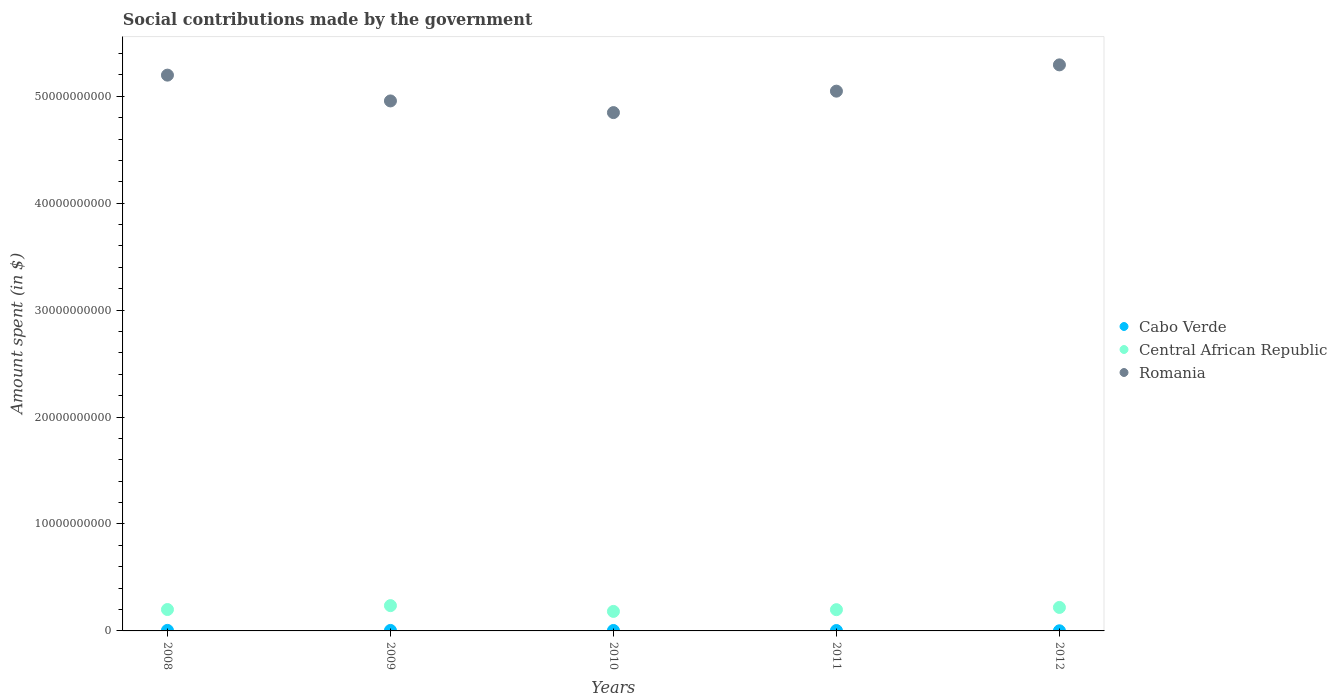How many different coloured dotlines are there?
Your answer should be compact. 3. What is the amount spent on social contributions in Central African Republic in 2012?
Provide a short and direct response. 2.20e+09. Across all years, what is the maximum amount spent on social contributions in Romania?
Offer a very short reply. 5.29e+1. Across all years, what is the minimum amount spent on social contributions in Romania?
Provide a short and direct response. 4.85e+1. In which year was the amount spent on social contributions in Central African Republic maximum?
Offer a very short reply. 2009. In which year was the amount spent on social contributions in Romania minimum?
Your answer should be compact. 2010. What is the total amount spent on social contributions in Central African Republic in the graph?
Make the answer very short. 1.04e+1. What is the difference between the amount spent on social contributions in Romania in 2009 and that in 2012?
Offer a terse response. -3.37e+09. What is the difference between the amount spent on social contributions in Cabo Verde in 2009 and the amount spent on social contributions in Romania in 2010?
Provide a succinct answer. -4.84e+1. What is the average amount spent on social contributions in Cabo Verde per year?
Provide a succinct answer. 3.73e+07. In the year 2008, what is the difference between the amount spent on social contributions in Central African Republic and amount spent on social contributions in Cabo Verde?
Ensure brevity in your answer.  1.95e+09. What is the ratio of the amount spent on social contributions in Central African Republic in 2009 to that in 2010?
Your answer should be very brief. 1.3. Is the amount spent on social contributions in Romania in 2008 less than that in 2012?
Offer a terse response. Yes. What is the difference between the highest and the second highest amount spent on social contributions in Cabo Verde?
Your answer should be very brief. 4.24e+06. What is the difference between the highest and the lowest amount spent on social contributions in Central African Republic?
Your answer should be compact. 5.41e+08. In how many years, is the amount spent on social contributions in Central African Republic greater than the average amount spent on social contributions in Central African Republic taken over all years?
Ensure brevity in your answer.  2. Does the amount spent on social contributions in Romania monotonically increase over the years?
Make the answer very short. No. Is the amount spent on social contributions in Central African Republic strictly less than the amount spent on social contributions in Romania over the years?
Make the answer very short. Yes. How many years are there in the graph?
Offer a terse response. 5. Are the values on the major ticks of Y-axis written in scientific E-notation?
Ensure brevity in your answer.  No. Does the graph contain any zero values?
Your response must be concise. No. Does the graph contain grids?
Keep it short and to the point. No. How many legend labels are there?
Provide a short and direct response. 3. How are the legend labels stacked?
Your response must be concise. Vertical. What is the title of the graph?
Your answer should be very brief. Social contributions made by the government. What is the label or title of the Y-axis?
Your answer should be compact. Amount spent (in $). What is the Amount spent (in $) in Cabo Verde in 2008?
Ensure brevity in your answer.  4.98e+07. What is the Amount spent (in $) in Central African Republic in 2008?
Offer a terse response. 2.00e+09. What is the Amount spent (in $) in Romania in 2008?
Provide a short and direct response. 5.20e+1. What is the Amount spent (in $) of Cabo Verde in 2009?
Keep it short and to the point. 4.56e+07. What is the Amount spent (in $) in Central African Republic in 2009?
Make the answer very short. 2.37e+09. What is the Amount spent (in $) in Romania in 2009?
Your response must be concise. 4.96e+1. What is the Amount spent (in $) in Cabo Verde in 2010?
Your answer should be very brief. 4.19e+07. What is the Amount spent (in $) in Central African Republic in 2010?
Give a very brief answer. 1.82e+09. What is the Amount spent (in $) of Romania in 2010?
Make the answer very short. 4.85e+1. What is the Amount spent (in $) in Cabo Verde in 2011?
Offer a very short reply. 3.65e+07. What is the Amount spent (in $) in Central African Republic in 2011?
Make the answer very short. 1.99e+09. What is the Amount spent (in $) in Romania in 2011?
Keep it short and to the point. 5.05e+1. What is the Amount spent (in $) in Cabo Verde in 2012?
Offer a very short reply. 1.29e+07. What is the Amount spent (in $) of Central African Republic in 2012?
Offer a terse response. 2.20e+09. What is the Amount spent (in $) of Romania in 2012?
Make the answer very short. 5.29e+1. Across all years, what is the maximum Amount spent (in $) of Cabo Verde?
Provide a succinct answer. 4.98e+07. Across all years, what is the maximum Amount spent (in $) in Central African Republic?
Offer a terse response. 2.37e+09. Across all years, what is the maximum Amount spent (in $) of Romania?
Your response must be concise. 5.29e+1. Across all years, what is the minimum Amount spent (in $) in Cabo Verde?
Offer a very short reply. 1.29e+07. Across all years, what is the minimum Amount spent (in $) in Central African Republic?
Give a very brief answer. 1.82e+09. Across all years, what is the minimum Amount spent (in $) in Romania?
Keep it short and to the point. 4.85e+1. What is the total Amount spent (in $) in Cabo Verde in the graph?
Offer a terse response. 1.87e+08. What is the total Amount spent (in $) in Central African Republic in the graph?
Offer a terse response. 1.04e+1. What is the total Amount spent (in $) in Romania in the graph?
Offer a very short reply. 2.53e+11. What is the difference between the Amount spent (in $) in Cabo Verde in 2008 and that in 2009?
Your response must be concise. 4.24e+06. What is the difference between the Amount spent (in $) of Central African Republic in 2008 and that in 2009?
Give a very brief answer. -3.65e+08. What is the difference between the Amount spent (in $) of Romania in 2008 and that in 2009?
Offer a very short reply. 2.41e+09. What is the difference between the Amount spent (in $) in Cabo Verde in 2008 and that in 2010?
Provide a succinct answer. 7.89e+06. What is the difference between the Amount spent (in $) in Central African Republic in 2008 and that in 2010?
Your answer should be very brief. 1.76e+08. What is the difference between the Amount spent (in $) in Romania in 2008 and that in 2010?
Your answer should be very brief. 3.50e+09. What is the difference between the Amount spent (in $) in Cabo Verde in 2008 and that in 2011?
Provide a short and direct response. 1.33e+07. What is the difference between the Amount spent (in $) of Central African Republic in 2008 and that in 2011?
Your answer should be very brief. 1.32e+07. What is the difference between the Amount spent (in $) in Romania in 2008 and that in 2011?
Offer a very short reply. 1.50e+09. What is the difference between the Amount spent (in $) in Cabo Verde in 2008 and that in 2012?
Ensure brevity in your answer.  3.69e+07. What is the difference between the Amount spent (in $) of Central African Republic in 2008 and that in 2012?
Keep it short and to the point. -1.96e+08. What is the difference between the Amount spent (in $) in Romania in 2008 and that in 2012?
Your answer should be very brief. -9.60e+08. What is the difference between the Amount spent (in $) of Cabo Verde in 2009 and that in 2010?
Make the answer very short. 3.65e+06. What is the difference between the Amount spent (in $) in Central African Republic in 2009 and that in 2010?
Your answer should be very brief. 5.41e+08. What is the difference between the Amount spent (in $) of Romania in 2009 and that in 2010?
Provide a short and direct response. 1.09e+09. What is the difference between the Amount spent (in $) of Cabo Verde in 2009 and that in 2011?
Offer a very short reply. 9.01e+06. What is the difference between the Amount spent (in $) of Central African Republic in 2009 and that in 2011?
Keep it short and to the point. 3.78e+08. What is the difference between the Amount spent (in $) of Romania in 2009 and that in 2011?
Offer a very short reply. -9.14e+08. What is the difference between the Amount spent (in $) of Cabo Verde in 2009 and that in 2012?
Make the answer very short. 3.27e+07. What is the difference between the Amount spent (in $) in Central African Republic in 2009 and that in 2012?
Your response must be concise. 1.69e+08. What is the difference between the Amount spent (in $) of Romania in 2009 and that in 2012?
Provide a succinct answer. -3.37e+09. What is the difference between the Amount spent (in $) in Cabo Verde in 2010 and that in 2011?
Provide a short and direct response. 5.36e+06. What is the difference between the Amount spent (in $) of Central African Republic in 2010 and that in 2011?
Provide a succinct answer. -1.63e+08. What is the difference between the Amount spent (in $) of Romania in 2010 and that in 2011?
Provide a succinct answer. -2.01e+09. What is the difference between the Amount spent (in $) of Cabo Verde in 2010 and that in 2012?
Keep it short and to the point. 2.90e+07. What is the difference between the Amount spent (in $) of Central African Republic in 2010 and that in 2012?
Give a very brief answer. -3.72e+08. What is the difference between the Amount spent (in $) in Romania in 2010 and that in 2012?
Ensure brevity in your answer.  -4.46e+09. What is the difference between the Amount spent (in $) of Cabo Verde in 2011 and that in 2012?
Give a very brief answer. 2.36e+07. What is the difference between the Amount spent (in $) in Central African Republic in 2011 and that in 2012?
Provide a succinct answer. -2.09e+08. What is the difference between the Amount spent (in $) of Romania in 2011 and that in 2012?
Make the answer very short. -2.46e+09. What is the difference between the Amount spent (in $) in Cabo Verde in 2008 and the Amount spent (in $) in Central African Republic in 2009?
Your answer should be compact. -2.32e+09. What is the difference between the Amount spent (in $) in Cabo Verde in 2008 and the Amount spent (in $) in Romania in 2009?
Ensure brevity in your answer.  -4.95e+1. What is the difference between the Amount spent (in $) of Central African Republic in 2008 and the Amount spent (in $) of Romania in 2009?
Make the answer very short. -4.76e+1. What is the difference between the Amount spent (in $) of Cabo Verde in 2008 and the Amount spent (in $) of Central African Republic in 2010?
Keep it short and to the point. -1.78e+09. What is the difference between the Amount spent (in $) of Cabo Verde in 2008 and the Amount spent (in $) of Romania in 2010?
Make the answer very short. -4.84e+1. What is the difference between the Amount spent (in $) in Central African Republic in 2008 and the Amount spent (in $) in Romania in 2010?
Give a very brief answer. -4.65e+1. What is the difference between the Amount spent (in $) in Cabo Verde in 2008 and the Amount spent (in $) in Central African Republic in 2011?
Ensure brevity in your answer.  -1.94e+09. What is the difference between the Amount spent (in $) in Cabo Verde in 2008 and the Amount spent (in $) in Romania in 2011?
Provide a succinct answer. -5.04e+1. What is the difference between the Amount spent (in $) in Central African Republic in 2008 and the Amount spent (in $) in Romania in 2011?
Provide a short and direct response. -4.85e+1. What is the difference between the Amount spent (in $) of Cabo Verde in 2008 and the Amount spent (in $) of Central African Republic in 2012?
Ensure brevity in your answer.  -2.15e+09. What is the difference between the Amount spent (in $) in Cabo Verde in 2008 and the Amount spent (in $) in Romania in 2012?
Keep it short and to the point. -5.29e+1. What is the difference between the Amount spent (in $) in Central African Republic in 2008 and the Amount spent (in $) in Romania in 2012?
Provide a succinct answer. -5.09e+1. What is the difference between the Amount spent (in $) in Cabo Verde in 2009 and the Amount spent (in $) in Central African Republic in 2010?
Offer a very short reply. -1.78e+09. What is the difference between the Amount spent (in $) of Cabo Verde in 2009 and the Amount spent (in $) of Romania in 2010?
Keep it short and to the point. -4.84e+1. What is the difference between the Amount spent (in $) of Central African Republic in 2009 and the Amount spent (in $) of Romania in 2010?
Your response must be concise. -4.61e+1. What is the difference between the Amount spent (in $) of Cabo Verde in 2009 and the Amount spent (in $) of Central African Republic in 2011?
Offer a very short reply. -1.94e+09. What is the difference between the Amount spent (in $) of Cabo Verde in 2009 and the Amount spent (in $) of Romania in 2011?
Your response must be concise. -5.04e+1. What is the difference between the Amount spent (in $) in Central African Republic in 2009 and the Amount spent (in $) in Romania in 2011?
Your answer should be compact. -4.81e+1. What is the difference between the Amount spent (in $) of Cabo Verde in 2009 and the Amount spent (in $) of Central African Republic in 2012?
Provide a short and direct response. -2.15e+09. What is the difference between the Amount spent (in $) of Cabo Verde in 2009 and the Amount spent (in $) of Romania in 2012?
Keep it short and to the point. -5.29e+1. What is the difference between the Amount spent (in $) of Central African Republic in 2009 and the Amount spent (in $) of Romania in 2012?
Your response must be concise. -5.06e+1. What is the difference between the Amount spent (in $) in Cabo Verde in 2010 and the Amount spent (in $) in Central African Republic in 2011?
Offer a terse response. -1.95e+09. What is the difference between the Amount spent (in $) in Cabo Verde in 2010 and the Amount spent (in $) in Romania in 2011?
Ensure brevity in your answer.  -5.04e+1. What is the difference between the Amount spent (in $) in Central African Republic in 2010 and the Amount spent (in $) in Romania in 2011?
Your answer should be very brief. -4.87e+1. What is the difference between the Amount spent (in $) of Cabo Verde in 2010 and the Amount spent (in $) of Central African Republic in 2012?
Ensure brevity in your answer.  -2.15e+09. What is the difference between the Amount spent (in $) in Cabo Verde in 2010 and the Amount spent (in $) in Romania in 2012?
Offer a terse response. -5.29e+1. What is the difference between the Amount spent (in $) in Central African Republic in 2010 and the Amount spent (in $) in Romania in 2012?
Your response must be concise. -5.11e+1. What is the difference between the Amount spent (in $) in Cabo Verde in 2011 and the Amount spent (in $) in Central African Republic in 2012?
Your answer should be very brief. -2.16e+09. What is the difference between the Amount spent (in $) in Cabo Verde in 2011 and the Amount spent (in $) in Romania in 2012?
Give a very brief answer. -5.29e+1. What is the difference between the Amount spent (in $) in Central African Republic in 2011 and the Amount spent (in $) in Romania in 2012?
Keep it short and to the point. -5.09e+1. What is the average Amount spent (in $) of Cabo Verde per year?
Make the answer very short. 3.73e+07. What is the average Amount spent (in $) in Central African Republic per year?
Offer a very short reply. 2.08e+09. What is the average Amount spent (in $) in Romania per year?
Give a very brief answer. 5.07e+1. In the year 2008, what is the difference between the Amount spent (in $) in Cabo Verde and Amount spent (in $) in Central African Republic?
Your answer should be compact. -1.95e+09. In the year 2008, what is the difference between the Amount spent (in $) in Cabo Verde and Amount spent (in $) in Romania?
Keep it short and to the point. -5.19e+1. In the year 2008, what is the difference between the Amount spent (in $) in Central African Republic and Amount spent (in $) in Romania?
Offer a very short reply. -5.00e+1. In the year 2009, what is the difference between the Amount spent (in $) in Cabo Verde and Amount spent (in $) in Central African Republic?
Your answer should be compact. -2.32e+09. In the year 2009, what is the difference between the Amount spent (in $) in Cabo Verde and Amount spent (in $) in Romania?
Your answer should be compact. -4.95e+1. In the year 2009, what is the difference between the Amount spent (in $) of Central African Republic and Amount spent (in $) of Romania?
Offer a very short reply. -4.72e+1. In the year 2010, what is the difference between the Amount spent (in $) of Cabo Verde and Amount spent (in $) of Central African Republic?
Offer a terse response. -1.78e+09. In the year 2010, what is the difference between the Amount spent (in $) of Cabo Verde and Amount spent (in $) of Romania?
Offer a very short reply. -4.84e+1. In the year 2010, what is the difference between the Amount spent (in $) in Central African Republic and Amount spent (in $) in Romania?
Give a very brief answer. -4.66e+1. In the year 2011, what is the difference between the Amount spent (in $) in Cabo Verde and Amount spent (in $) in Central African Republic?
Offer a terse response. -1.95e+09. In the year 2011, what is the difference between the Amount spent (in $) in Cabo Verde and Amount spent (in $) in Romania?
Offer a very short reply. -5.04e+1. In the year 2011, what is the difference between the Amount spent (in $) in Central African Republic and Amount spent (in $) in Romania?
Offer a very short reply. -4.85e+1. In the year 2012, what is the difference between the Amount spent (in $) in Cabo Verde and Amount spent (in $) in Central African Republic?
Your response must be concise. -2.18e+09. In the year 2012, what is the difference between the Amount spent (in $) of Cabo Verde and Amount spent (in $) of Romania?
Keep it short and to the point. -5.29e+1. In the year 2012, what is the difference between the Amount spent (in $) of Central African Republic and Amount spent (in $) of Romania?
Your answer should be very brief. -5.07e+1. What is the ratio of the Amount spent (in $) of Cabo Verde in 2008 to that in 2009?
Your response must be concise. 1.09. What is the ratio of the Amount spent (in $) in Central African Republic in 2008 to that in 2009?
Your answer should be compact. 0.85. What is the ratio of the Amount spent (in $) in Romania in 2008 to that in 2009?
Your answer should be very brief. 1.05. What is the ratio of the Amount spent (in $) of Cabo Verde in 2008 to that in 2010?
Make the answer very short. 1.19. What is the ratio of the Amount spent (in $) in Central African Republic in 2008 to that in 2010?
Ensure brevity in your answer.  1.1. What is the ratio of the Amount spent (in $) in Romania in 2008 to that in 2010?
Ensure brevity in your answer.  1.07. What is the ratio of the Amount spent (in $) in Cabo Verde in 2008 to that in 2011?
Ensure brevity in your answer.  1.36. What is the ratio of the Amount spent (in $) in Central African Republic in 2008 to that in 2011?
Your answer should be very brief. 1.01. What is the ratio of the Amount spent (in $) in Romania in 2008 to that in 2011?
Offer a terse response. 1.03. What is the ratio of the Amount spent (in $) of Cabo Verde in 2008 to that in 2012?
Offer a very short reply. 3.86. What is the ratio of the Amount spent (in $) in Central African Republic in 2008 to that in 2012?
Keep it short and to the point. 0.91. What is the ratio of the Amount spent (in $) in Romania in 2008 to that in 2012?
Ensure brevity in your answer.  0.98. What is the ratio of the Amount spent (in $) in Cabo Verde in 2009 to that in 2010?
Give a very brief answer. 1.09. What is the ratio of the Amount spent (in $) in Central African Republic in 2009 to that in 2010?
Provide a short and direct response. 1.3. What is the ratio of the Amount spent (in $) of Romania in 2009 to that in 2010?
Offer a very short reply. 1.02. What is the ratio of the Amount spent (in $) of Cabo Verde in 2009 to that in 2011?
Offer a terse response. 1.25. What is the ratio of the Amount spent (in $) of Central African Republic in 2009 to that in 2011?
Your answer should be very brief. 1.19. What is the ratio of the Amount spent (in $) in Romania in 2009 to that in 2011?
Your response must be concise. 0.98. What is the ratio of the Amount spent (in $) in Cabo Verde in 2009 to that in 2012?
Give a very brief answer. 3.53. What is the ratio of the Amount spent (in $) of Central African Republic in 2009 to that in 2012?
Ensure brevity in your answer.  1.08. What is the ratio of the Amount spent (in $) of Romania in 2009 to that in 2012?
Give a very brief answer. 0.94. What is the ratio of the Amount spent (in $) in Cabo Verde in 2010 to that in 2011?
Keep it short and to the point. 1.15. What is the ratio of the Amount spent (in $) in Central African Republic in 2010 to that in 2011?
Offer a very short reply. 0.92. What is the ratio of the Amount spent (in $) of Romania in 2010 to that in 2011?
Ensure brevity in your answer.  0.96. What is the ratio of the Amount spent (in $) in Cabo Verde in 2010 to that in 2012?
Provide a succinct answer. 3.25. What is the ratio of the Amount spent (in $) of Central African Republic in 2010 to that in 2012?
Provide a succinct answer. 0.83. What is the ratio of the Amount spent (in $) of Romania in 2010 to that in 2012?
Your response must be concise. 0.92. What is the ratio of the Amount spent (in $) in Cabo Verde in 2011 to that in 2012?
Offer a terse response. 2.83. What is the ratio of the Amount spent (in $) of Central African Republic in 2011 to that in 2012?
Ensure brevity in your answer.  0.9. What is the ratio of the Amount spent (in $) in Romania in 2011 to that in 2012?
Your answer should be very brief. 0.95. What is the difference between the highest and the second highest Amount spent (in $) in Cabo Verde?
Give a very brief answer. 4.24e+06. What is the difference between the highest and the second highest Amount spent (in $) of Central African Republic?
Your answer should be very brief. 1.69e+08. What is the difference between the highest and the second highest Amount spent (in $) of Romania?
Offer a terse response. 9.60e+08. What is the difference between the highest and the lowest Amount spent (in $) of Cabo Verde?
Give a very brief answer. 3.69e+07. What is the difference between the highest and the lowest Amount spent (in $) of Central African Republic?
Offer a very short reply. 5.41e+08. What is the difference between the highest and the lowest Amount spent (in $) of Romania?
Make the answer very short. 4.46e+09. 